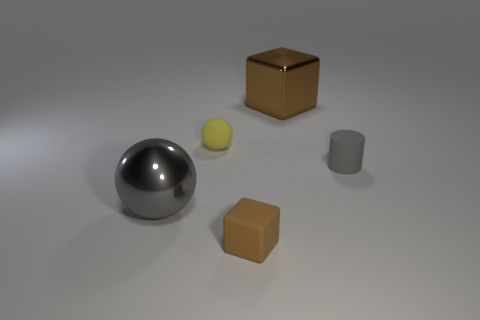Can you describe the objects in the center of the image? Centrally located in the image are a metallic sphere that reflects the environment, a smaller, pale yellow sphere, and an opaque gray cylinder. 